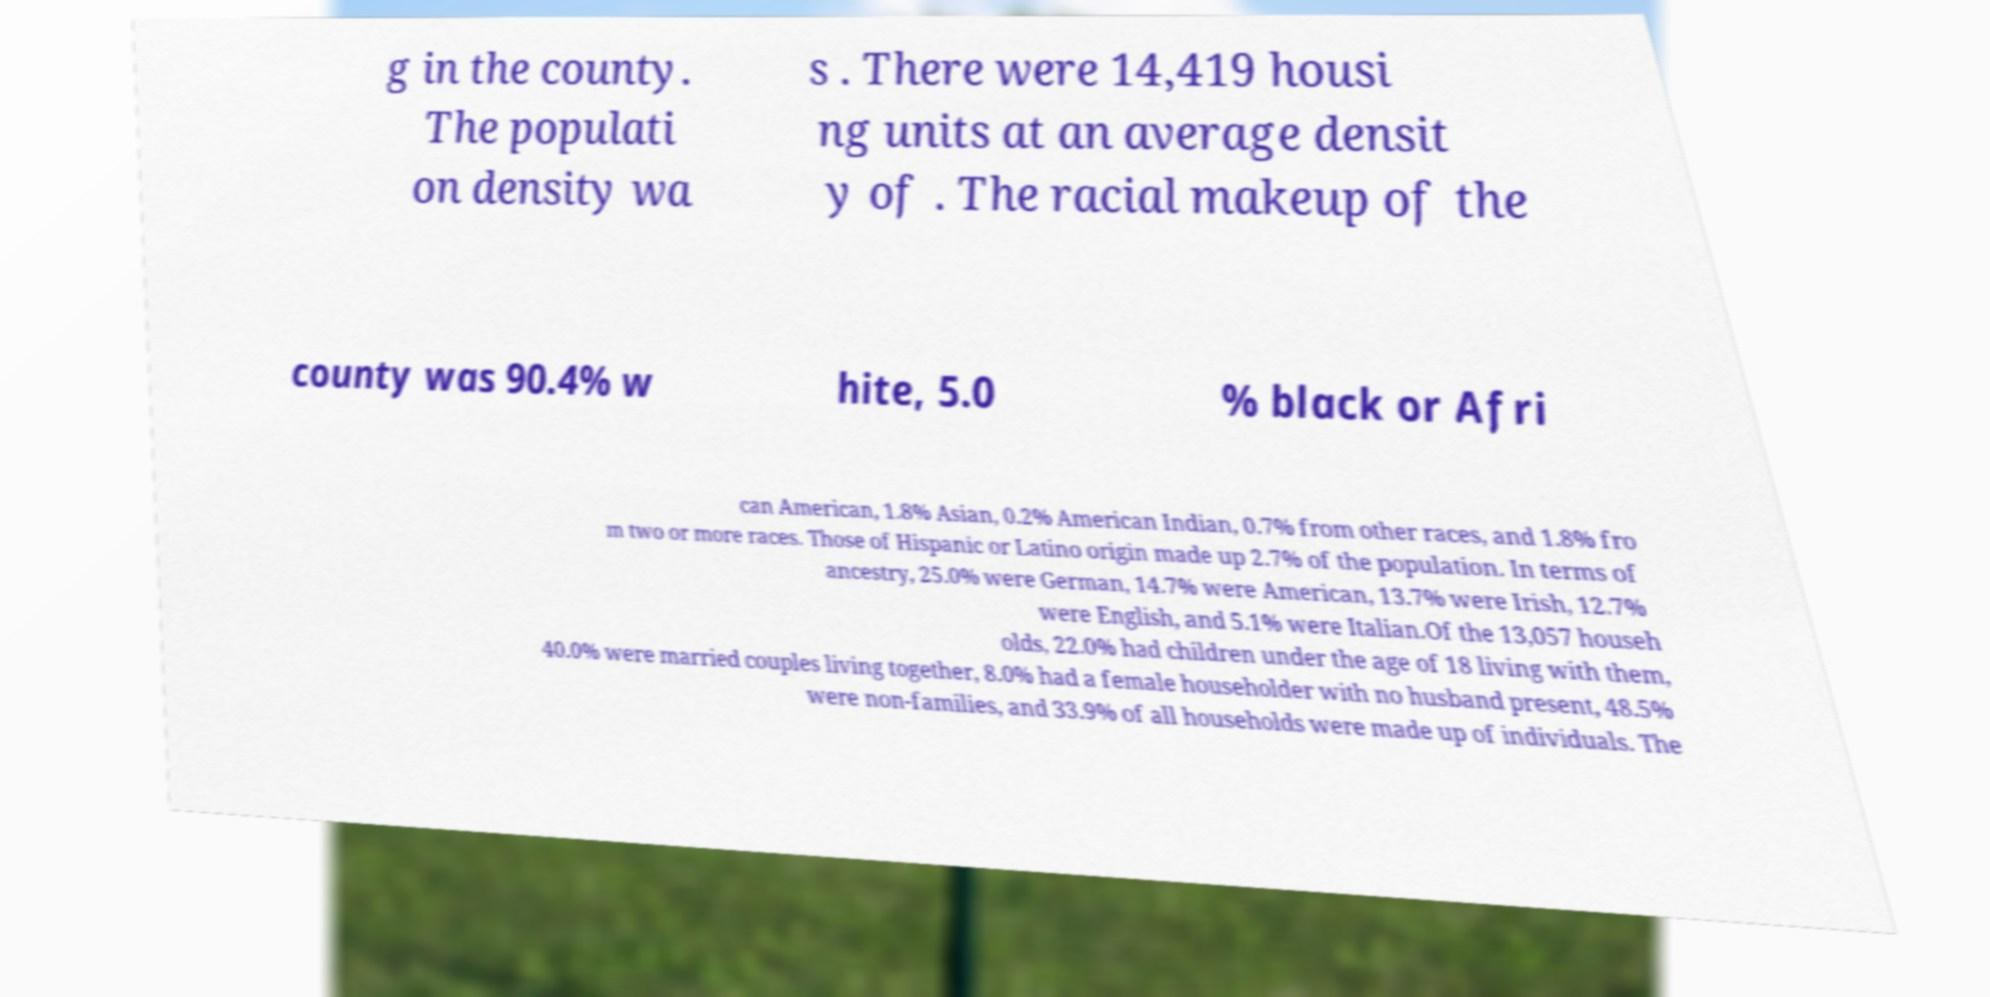Please identify and transcribe the text found in this image. g in the county. The populati on density wa s . There were 14,419 housi ng units at an average densit y of . The racial makeup of the county was 90.4% w hite, 5.0 % black or Afri can American, 1.8% Asian, 0.2% American Indian, 0.7% from other races, and 1.8% fro m two or more races. Those of Hispanic or Latino origin made up 2.7% of the population. In terms of ancestry, 25.0% were German, 14.7% were American, 13.7% were Irish, 12.7% were English, and 5.1% were Italian.Of the 13,057 househ olds, 22.0% had children under the age of 18 living with them, 40.0% were married couples living together, 8.0% had a female householder with no husband present, 48.5% were non-families, and 33.9% of all households were made up of individuals. The 